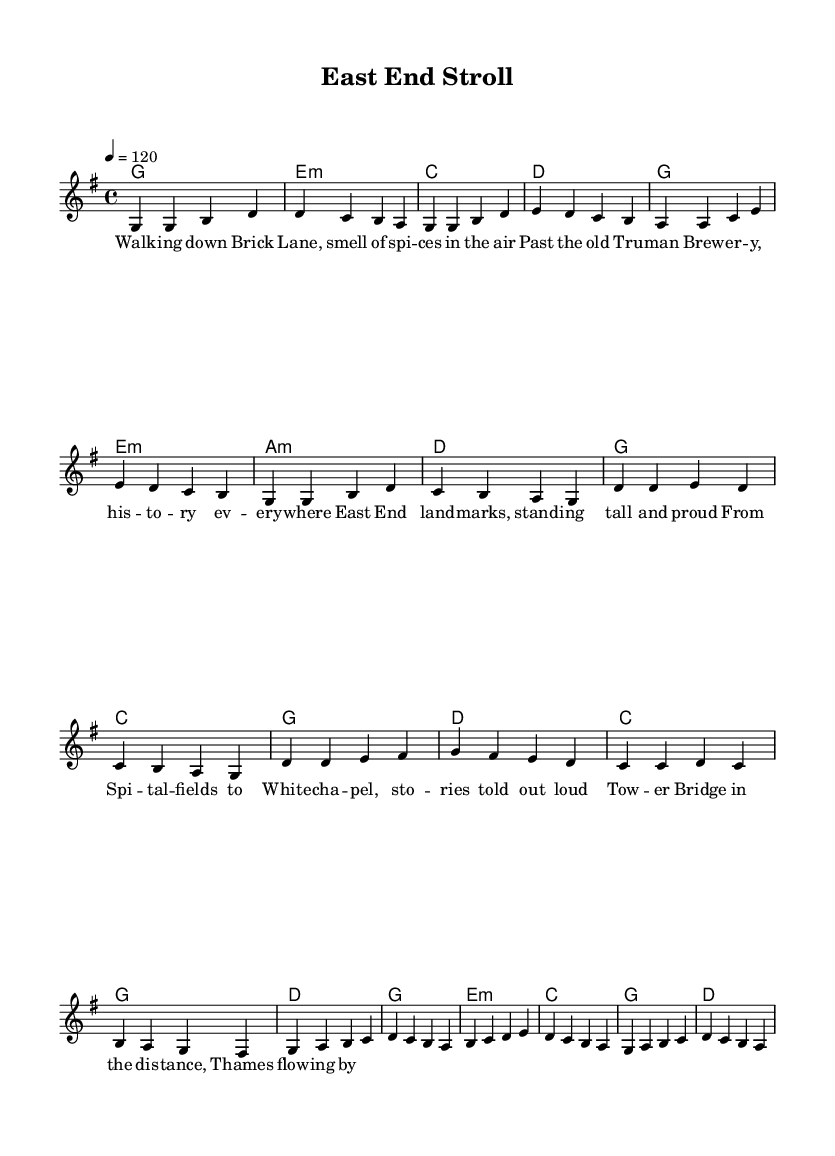What is the key signature of this music? The key signature indicates G major, which has one sharp (F sharp). This is determined by looking at the key signature notation at the beginning of the score.
Answer: G major What is the time signature of the piece? The time signature is 4/4, meaning there are four beats in each measure and the quarter note receives one beat. This can be observed at the start of the score in the time signature section.
Answer: 4/4 What is the tempo marking of this music? The tempo is marked as 120 beats per minute, indicating a moderately brisk pace. This information is located in the tempo indication at the start of the score, which specifies a tempo marking of 4 = 120.
Answer: 120 How many measures are in the verse section? The verse section consists of 8 measures, which can be counted by looking at the corresponding notation of the verse part before the chorus begins. Each complete set of notes between vertical lines (bar lines) represents a measure.
Answer: 8 What is the last chord in the bridge? The last chord in the bridge is D major, which is indicated in the chord changes aligned with the melody of that section. This can be determined by looking at the harmony section under the bridge lyrics.
Answer: D What distinguishes the chorus from the verse musically? The chorus features a different melodic pattern and harmonies, and is generally structured to be more repetitive and catchy than the verse. Analyzing the melody and harmonies reveals a distinct shift in musical direction where the chorus introduces a new melodic focus.
Answer: Different melodic pattern What is a notable landmark mentioned in the lyrics? The lyrics refer to Brick Lane, a famous street in the East End known for its multicultural atmosphere and history. This information can be directly extracted from the verse lyrics where it is explicitly stated.
Answer: Brick Lane 